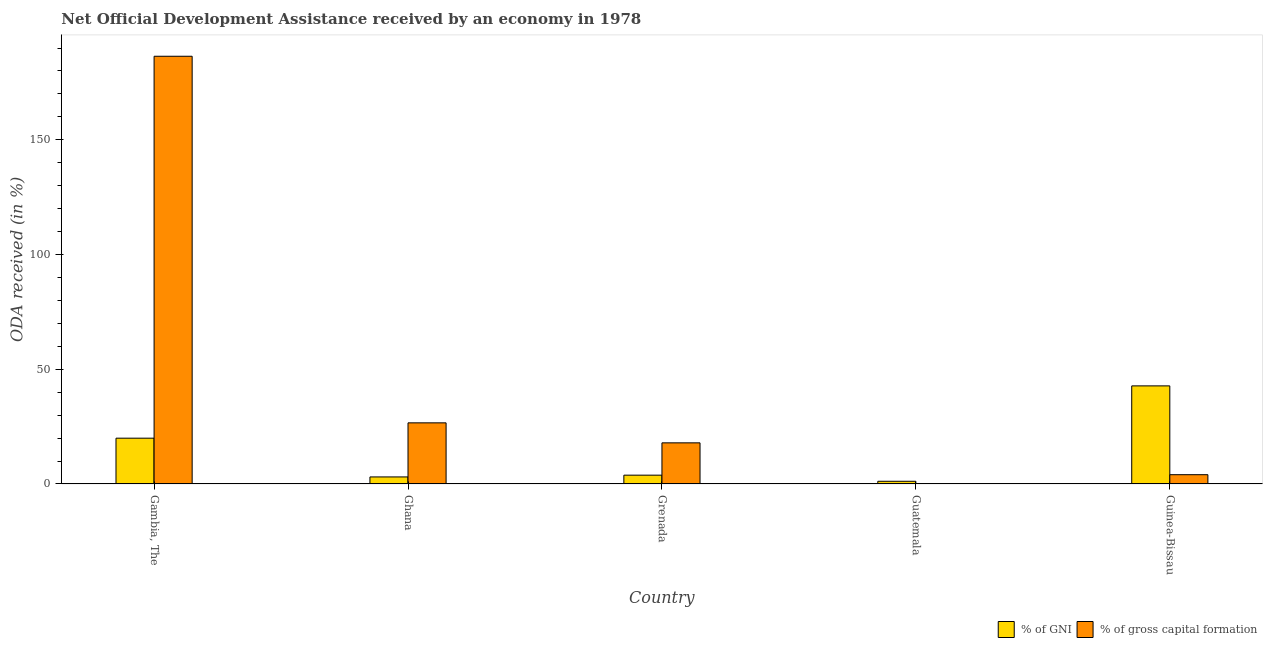Are the number of bars per tick equal to the number of legend labels?
Your answer should be very brief. Yes. Are the number of bars on each tick of the X-axis equal?
Keep it short and to the point. Yes. What is the label of the 4th group of bars from the left?
Provide a short and direct response. Guatemala. What is the oda received as percentage of gross capital formation in Grenada?
Ensure brevity in your answer.  17.92. Across all countries, what is the maximum oda received as percentage of gni?
Your answer should be very brief. 42.75. Across all countries, what is the minimum oda received as percentage of gni?
Your answer should be compact. 1.18. In which country was the oda received as percentage of gross capital formation maximum?
Keep it short and to the point. Gambia, The. In which country was the oda received as percentage of gni minimum?
Give a very brief answer. Guatemala. What is the total oda received as percentage of gross capital formation in the graph?
Your answer should be very brief. 235.07. What is the difference between the oda received as percentage of gni in Ghana and that in Grenada?
Give a very brief answer. -0.77. What is the difference between the oda received as percentage of gross capital formation in Grenada and the oda received as percentage of gni in Guinea-Bissau?
Keep it short and to the point. -24.83. What is the average oda received as percentage of gni per country?
Your answer should be compact. 14.16. What is the difference between the oda received as percentage of gross capital formation and oda received as percentage of gni in Ghana?
Your response must be concise. 23.57. What is the ratio of the oda received as percentage of gni in Gambia, The to that in Guinea-Bissau?
Your answer should be compact. 0.47. Is the oda received as percentage of gni in Grenada less than that in Guinea-Bissau?
Provide a succinct answer. Yes. What is the difference between the highest and the second highest oda received as percentage of gni?
Provide a short and direct response. 22.79. What is the difference between the highest and the lowest oda received as percentage of gni?
Offer a very short reply. 41.58. What does the 2nd bar from the left in Grenada represents?
Give a very brief answer. % of gross capital formation. What does the 2nd bar from the right in Ghana represents?
Keep it short and to the point. % of GNI. How many bars are there?
Offer a terse response. 10. Are all the bars in the graph horizontal?
Your answer should be very brief. No. How many countries are there in the graph?
Provide a short and direct response. 5. What is the difference between two consecutive major ticks on the Y-axis?
Provide a short and direct response. 50. Does the graph contain grids?
Offer a very short reply. No. How many legend labels are there?
Your answer should be very brief. 2. What is the title of the graph?
Make the answer very short. Net Official Development Assistance received by an economy in 1978. Does "Malaria" appear as one of the legend labels in the graph?
Your response must be concise. No. What is the label or title of the X-axis?
Your answer should be very brief. Country. What is the label or title of the Y-axis?
Offer a very short reply. ODA received (in %). What is the ODA received (in %) of % of GNI in Gambia, The?
Keep it short and to the point. 19.96. What is the ODA received (in %) in % of gross capital formation in Gambia, The?
Your response must be concise. 186.41. What is the ODA received (in %) in % of GNI in Ghana?
Offer a terse response. 3.07. What is the ODA received (in %) in % of gross capital formation in Ghana?
Offer a very short reply. 26.64. What is the ODA received (in %) in % of GNI in Grenada?
Offer a terse response. 3.84. What is the ODA received (in %) of % of gross capital formation in Grenada?
Offer a terse response. 17.92. What is the ODA received (in %) of % of GNI in Guatemala?
Ensure brevity in your answer.  1.18. What is the ODA received (in %) in % of gross capital formation in Guatemala?
Your response must be concise. 0.04. What is the ODA received (in %) in % of GNI in Guinea-Bissau?
Your answer should be very brief. 42.75. What is the ODA received (in %) in % of gross capital formation in Guinea-Bissau?
Ensure brevity in your answer.  4.05. Across all countries, what is the maximum ODA received (in %) in % of GNI?
Your response must be concise. 42.75. Across all countries, what is the maximum ODA received (in %) in % of gross capital formation?
Give a very brief answer. 186.41. Across all countries, what is the minimum ODA received (in %) in % of GNI?
Offer a very short reply. 1.18. Across all countries, what is the minimum ODA received (in %) in % of gross capital formation?
Your answer should be very brief. 0.04. What is the total ODA received (in %) of % of GNI in the graph?
Ensure brevity in your answer.  70.8. What is the total ODA received (in %) in % of gross capital formation in the graph?
Give a very brief answer. 235.07. What is the difference between the ODA received (in %) in % of GNI in Gambia, The and that in Ghana?
Provide a succinct answer. 16.89. What is the difference between the ODA received (in %) of % of gross capital formation in Gambia, The and that in Ghana?
Provide a short and direct response. 159.77. What is the difference between the ODA received (in %) of % of GNI in Gambia, The and that in Grenada?
Provide a succinct answer. 16.12. What is the difference between the ODA received (in %) of % of gross capital formation in Gambia, The and that in Grenada?
Your response must be concise. 168.49. What is the difference between the ODA received (in %) of % of GNI in Gambia, The and that in Guatemala?
Your response must be concise. 18.78. What is the difference between the ODA received (in %) of % of gross capital formation in Gambia, The and that in Guatemala?
Offer a terse response. 186.37. What is the difference between the ODA received (in %) of % of GNI in Gambia, The and that in Guinea-Bissau?
Your response must be concise. -22.79. What is the difference between the ODA received (in %) of % of gross capital formation in Gambia, The and that in Guinea-Bissau?
Provide a short and direct response. 182.37. What is the difference between the ODA received (in %) of % of GNI in Ghana and that in Grenada?
Ensure brevity in your answer.  -0.77. What is the difference between the ODA received (in %) in % of gross capital formation in Ghana and that in Grenada?
Your answer should be very brief. 8.72. What is the difference between the ODA received (in %) of % of GNI in Ghana and that in Guatemala?
Make the answer very short. 1.89. What is the difference between the ODA received (in %) of % of gross capital formation in Ghana and that in Guatemala?
Your answer should be compact. 26.6. What is the difference between the ODA received (in %) in % of GNI in Ghana and that in Guinea-Bissau?
Give a very brief answer. -39.68. What is the difference between the ODA received (in %) of % of gross capital formation in Ghana and that in Guinea-Bissau?
Provide a succinct answer. 22.6. What is the difference between the ODA received (in %) of % of GNI in Grenada and that in Guatemala?
Ensure brevity in your answer.  2.66. What is the difference between the ODA received (in %) in % of gross capital formation in Grenada and that in Guatemala?
Your answer should be very brief. 17.88. What is the difference between the ODA received (in %) of % of GNI in Grenada and that in Guinea-Bissau?
Provide a short and direct response. -38.91. What is the difference between the ODA received (in %) in % of gross capital formation in Grenada and that in Guinea-Bissau?
Your response must be concise. 13.88. What is the difference between the ODA received (in %) of % of GNI in Guatemala and that in Guinea-Bissau?
Keep it short and to the point. -41.58. What is the difference between the ODA received (in %) of % of gross capital formation in Guatemala and that in Guinea-Bissau?
Provide a succinct answer. -4. What is the difference between the ODA received (in %) of % of GNI in Gambia, The and the ODA received (in %) of % of gross capital formation in Ghana?
Your response must be concise. -6.68. What is the difference between the ODA received (in %) in % of GNI in Gambia, The and the ODA received (in %) in % of gross capital formation in Grenada?
Ensure brevity in your answer.  2.04. What is the difference between the ODA received (in %) in % of GNI in Gambia, The and the ODA received (in %) in % of gross capital formation in Guatemala?
Give a very brief answer. 19.92. What is the difference between the ODA received (in %) of % of GNI in Gambia, The and the ODA received (in %) of % of gross capital formation in Guinea-Bissau?
Make the answer very short. 15.91. What is the difference between the ODA received (in %) in % of GNI in Ghana and the ODA received (in %) in % of gross capital formation in Grenada?
Offer a terse response. -14.85. What is the difference between the ODA received (in %) of % of GNI in Ghana and the ODA received (in %) of % of gross capital formation in Guatemala?
Make the answer very short. 3.03. What is the difference between the ODA received (in %) in % of GNI in Ghana and the ODA received (in %) in % of gross capital formation in Guinea-Bissau?
Make the answer very short. -0.98. What is the difference between the ODA received (in %) in % of GNI in Grenada and the ODA received (in %) in % of gross capital formation in Guatemala?
Your answer should be compact. 3.8. What is the difference between the ODA received (in %) of % of GNI in Grenada and the ODA received (in %) of % of gross capital formation in Guinea-Bissau?
Offer a very short reply. -0.21. What is the difference between the ODA received (in %) of % of GNI in Guatemala and the ODA received (in %) of % of gross capital formation in Guinea-Bissau?
Make the answer very short. -2.87. What is the average ODA received (in %) of % of GNI per country?
Your answer should be very brief. 14.16. What is the average ODA received (in %) in % of gross capital formation per country?
Give a very brief answer. 47.01. What is the difference between the ODA received (in %) of % of GNI and ODA received (in %) of % of gross capital formation in Gambia, The?
Provide a short and direct response. -166.45. What is the difference between the ODA received (in %) in % of GNI and ODA received (in %) in % of gross capital formation in Ghana?
Your answer should be compact. -23.57. What is the difference between the ODA received (in %) of % of GNI and ODA received (in %) of % of gross capital formation in Grenada?
Your answer should be compact. -14.08. What is the difference between the ODA received (in %) in % of GNI and ODA received (in %) in % of gross capital formation in Guatemala?
Give a very brief answer. 1.13. What is the difference between the ODA received (in %) in % of GNI and ODA received (in %) in % of gross capital formation in Guinea-Bissau?
Ensure brevity in your answer.  38.71. What is the ratio of the ODA received (in %) in % of GNI in Gambia, The to that in Ghana?
Your answer should be very brief. 6.5. What is the ratio of the ODA received (in %) of % of gross capital formation in Gambia, The to that in Ghana?
Offer a very short reply. 7. What is the ratio of the ODA received (in %) in % of GNI in Gambia, The to that in Grenada?
Make the answer very short. 5.2. What is the ratio of the ODA received (in %) in % of gross capital formation in Gambia, The to that in Grenada?
Your response must be concise. 10.4. What is the ratio of the ODA received (in %) in % of GNI in Gambia, The to that in Guatemala?
Provide a short and direct response. 16.95. What is the ratio of the ODA received (in %) of % of gross capital formation in Gambia, The to that in Guatemala?
Your answer should be compact. 4174. What is the ratio of the ODA received (in %) of % of GNI in Gambia, The to that in Guinea-Bissau?
Offer a very short reply. 0.47. What is the ratio of the ODA received (in %) of % of gross capital formation in Gambia, The to that in Guinea-Bissau?
Your answer should be compact. 46.06. What is the ratio of the ODA received (in %) of % of GNI in Ghana to that in Grenada?
Provide a short and direct response. 0.8. What is the ratio of the ODA received (in %) in % of gross capital formation in Ghana to that in Grenada?
Offer a very short reply. 1.49. What is the ratio of the ODA received (in %) in % of GNI in Ghana to that in Guatemala?
Offer a terse response. 2.61. What is the ratio of the ODA received (in %) in % of gross capital formation in Ghana to that in Guatemala?
Your answer should be compact. 596.59. What is the ratio of the ODA received (in %) of % of GNI in Ghana to that in Guinea-Bissau?
Keep it short and to the point. 0.07. What is the ratio of the ODA received (in %) of % of gross capital formation in Ghana to that in Guinea-Bissau?
Your response must be concise. 6.58. What is the ratio of the ODA received (in %) of % of GNI in Grenada to that in Guatemala?
Provide a short and direct response. 3.26. What is the ratio of the ODA received (in %) in % of gross capital formation in Grenada to that in Guatemala?
Ensure brevity in your answer.  401.33. What is the ratio of the ODA received (in %) in % of GNI in Grenada to that in Guinea-Bissau?
Give a very brief answer. 0.09. What is the ratio of the ODA received (in %) in % of gross capital formation in Grenada to that in Guinea-Bissau?
Your answer should be compact. 4.43. What is the ratio of the ODA received (in %) in % of GNI in Guatemala to that in Guinea-Bissau?
Offer a very short reply. 0.03. What is the ratio of the ODA received (in %) of % of gross capital formation in Guatemala to that in Guinea-Bissau?
Keep it short and to the point. 0.01. What is the difference between the highest and the second highest ODA received (in %) in % of GNI?
Offer a terse response. 22.79. What is the difference between the highest and the second highest ODA received (in %) in % of gross capital formation?
Your response must be concise. 159.77. What is the difference between the highest and the lowest ODA received (in %) in % of GNI?
Make the answer very short. 41.58. What is the difference between the highest and the lowest ODA received (in %) of % of gross capital formation?
Offer a terse response. 186.37. 